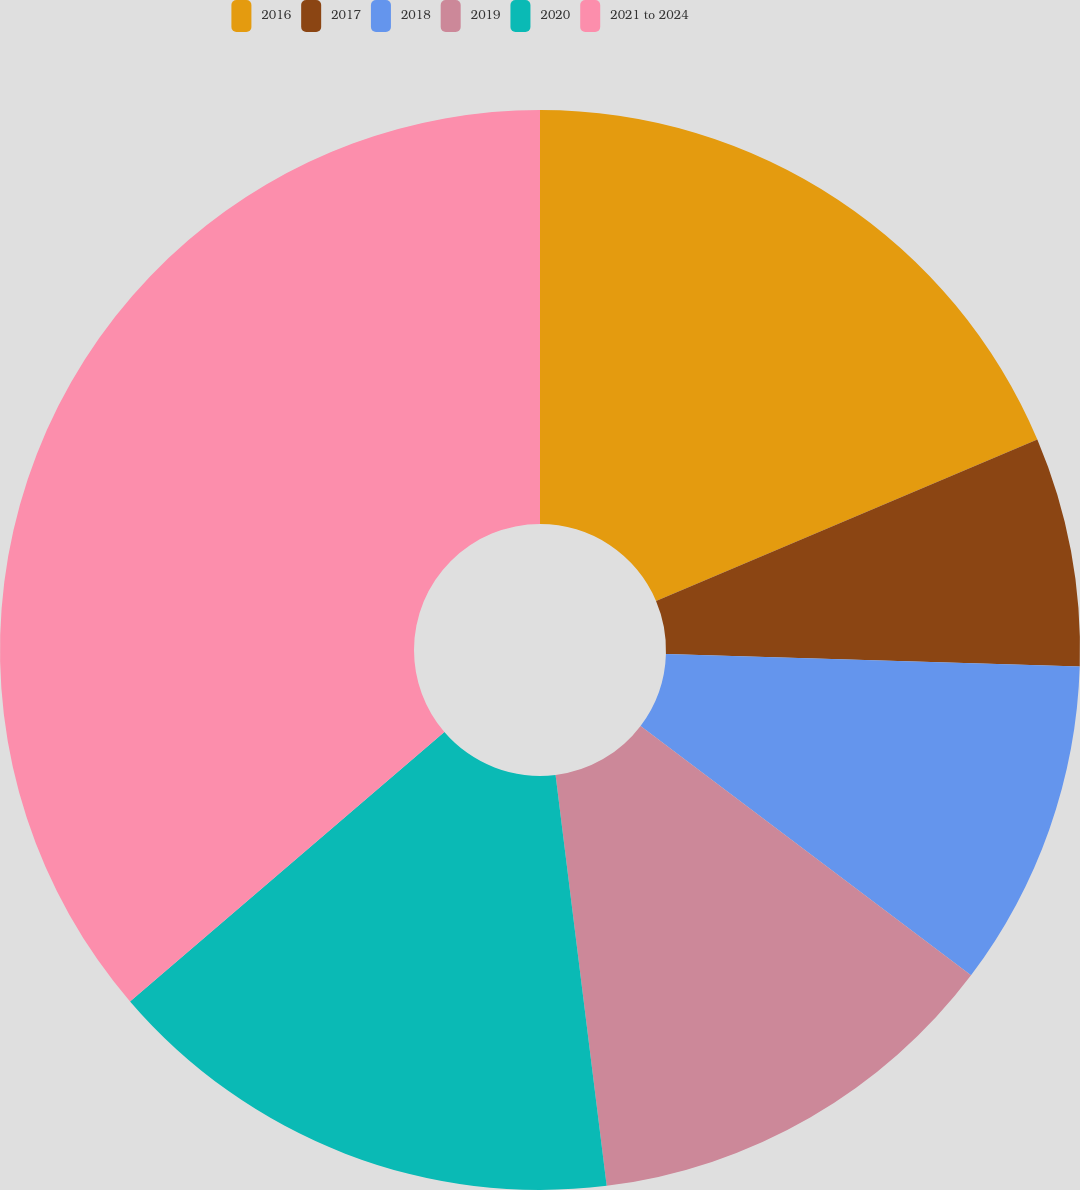Convert chart to OTSL. <chart><loc_0><loc_0><loc_500><loc_500><pie_chart><fcel>2016<fcel>2017<fcel>2018<fcel>2019<fcel>2020<fcel>2021 to 2024<nl><fcel>18.63%<fcel>6.86%<fcel>9.8%<fcel>12.74%<fcel>15.69%<fcel>36.28%<nl></chart> 